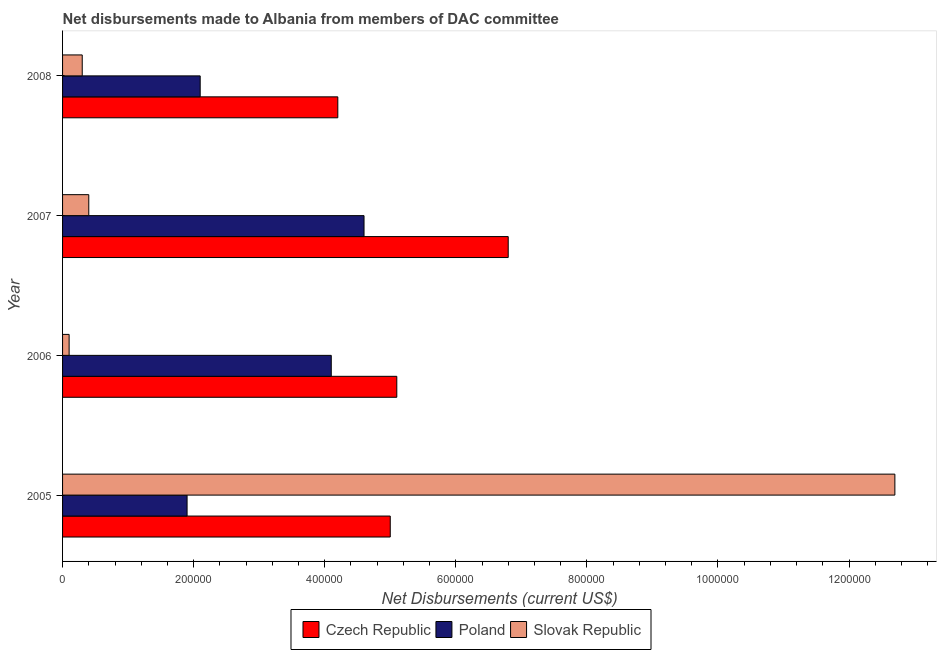How many different coloured bars are there?
Your response must be concise. 3. How many groups of bars are there?
Provide a succinct answer. 4. How many bars are there on the 2nd tick from the top?
Make the answer very short. 3. In how many cases, is the number of bars for a given year not equal to the number of legend labels?
Give a very brief answer. 0. What is the net disbursements made by poland in 2007?
Your response must be concise. 4.60e+05. Across all years, what is the maximum net disbursements made by czech republic?
Your answer should be very brief. 6.80e+05. Across all years, what is the minimum net disbursements made by czech republic?
Make the answer very short. 4.20e+05. What is the total net disbursements made by czech republic in the graph?
Offer a very short reply. 2.11e+06. What is the difference between the net disbursements made by slovak republic in 2005 and that in 2007?
Your response must be concise. 1.23e+06. What is the difference between the net disbursements made by poland in 2006 and the net disbursements made by czech republic in 2008?
Make the answer very short. -10000. What is the average net disbursements made by czech republic per year?
Your answer should be very brief. 5.28e+05. In the year 2007, what is the difference between the net disbursements made by czech republic and net disbursements made by slovak republic?
Provide a short and direct response. 6.40e+05. In how many years, is the net disbursements made by poland greater than 200000 US$?
Your answer should be very brief. 3. What is the ratio of the net disbursements made by czech republic in 2005 to that in 2008?
Provide a succinct answer. 1.19. Is the net disbursements made by czech republic in 2006 less than that in 2007?
Provide a succinct answer. Yes. Is the difference between the net disbursements made by czech republic in 2007 and 2008 greater than the difference between the net disbursements made by poland in 2007 and 2008?
Give a very brief answer. Yes. What is the difference between the highest and the second highest net disbursements made by czech republic?
Your answer should be very brief. 1.70e+05. What is the difference between the highest and the lowest net disbursements made by poland?
Provide a short and direct response. 2.70e+05. What does the 1st bar from the top in 2007 represents?
Provide a short and direct response. Slovak Republic. How many bars are there?
Provide a short and direct response. 12. Are all the bars in the graph horizontal?
Provide a short and direct response. Yes. Are the values on the major ticks of X-axis written in scientific E-notation?
Provide a succinct answer. No. Does the graph contain any zero values?
Keep it short and to the point. No. Does the graph contain grids?
Keep it short and to the point. No. How many legend labels are there?
Keep it short and to the point. 3. What is the title of the graph?
Ensure brevity in your answer.  Net disbursements made to Albania from members of DAC committee. Does "Industrial Nitrous Oxide" appear as one of the legend labels in the graph?
Make the answer very short. No. What is the label or title of the X-axis?
Your response must be concise. Net Disbursements (current US$). What is the Net Disbursements (current US$) of Czech Republic in 2005?
Give a very brief answer. 5.00e+05. What is the Net Disbursements (current US$) in Poland in 2005?
Keep it short and to the point. 1.90e+05. What is the Net Disbursements (current US$) of Slovak Republic in 2005?
Keep it short and to the point. 1.27e+06. What is the Net Disbursements (current US$) in Czech Republic in 2006?
Make the answer very short. 5.10e+05. What is the Net Disbursements (current US$) of Poland in 2006?
Give a very brief answer. 4.10e+05. What is the Net Disbursements (current US$) of Czech Republic in 2007?
Keep it short and to the point. 6.80e+05. What is the Net Disbursements (current US$) in Poland in 2007?
Offer a terse response. 4.60e+05. What is the Net Disbursements (current US$) of Poland in 2008?
Offer a terse response. 2.10e+05. Across all years, what is the maximum Net Disbursements (current US$) in Czech Republic?
Offer a very short reply. 6.80e+05. Across all years, what is the maximum Net Disbursements (current US$) of Slovak Republic?
Provide a succinct answer. 1.27e+06. Across all years, what is the minimum Net Disbursements (current US$) in Czech Republic?
Provide a succinct answer. 4.20e+05. Across all years, what is the minimum Net Disbursements (current US$) in Poland?
Provide a succinct answer. 1.90e+05. Across all years, what is the minimum Net Disbursements (current US$) of Slovak Republic?
Offer a terse response. 10000. What is the total Net Disbursements (current US$) of Czech Republic in the graph?
Ensure brevity in your answer.  2.11e+06. What is the total Net Disbursements (current US$) in Poland in the graph?
Offer a terse response. 1.27e+06. What is the total Net Disbursements (current US$) of Slovak Republic in the graph?
Keep it short and to the point. 1.35e+06. What is the difference between the Net Disbursements (current US$) of Poland in 2005 and that in 2006?
Your answer should be very brief. -2.20e+05. What is the difference between the Net Disbursements (current US$) in Slovak Republic in 2005 and that in 2006?
Ensure brevity in your answer.  1.26e+06. What is the difference between the Net Disbursements (current US$) in Czech Republic in 2005 and that in 2007?
Your response must be concise. -1.80e+05. What is the difference between the Net Disbursements (current US$) of Slovak Republic in 2005 and that in 2007?
Provide a succinct answer. 1.23e+06. What is the difference between the Net Disbursements (current US$) of Czech Republic in 2005 and that in 2008?
Keep it short and to the point. 8.00e+04. What is the difference between the Net Disbursements (current US$) of Poland in 2005 and that in 2008?
Make the answer very short. -2.00e+04. What is the difference between the Net Disbursements (current US$) of Slovak Republic in 2005 and that in 2008?
Ensure brevity in your answer.  1.24e+06. What is the difference between the Net Disbursements (current US$) of Poland in 2006 and that in 2007?
Give a very brief answer. -5.00e+04. What is the difference between the Net Disbursements (current US$) in Slovak Republic in 2006 and that in 2007?
Provide a succinct answer. -3.00e+04. What is the difference between the Net Disbursements (current US$) of Czech Republic in 2006 and that in 2008?
Keep it short and to the point. 9.00e+04. What is the difference between the Net Disbursements (current US$) in Poland in 2006 and that in 2008?
Give a very brief answer. 2.00e+05. What is the difference between the Net Disbursements (current US$) in Poland in 2007 and that in 2008?
Your answer should be very brief. 2.50e+05. What is the difference between the Net Disbursements (current US$) in Czech Republic in 2005 and the Net Disbursements (current US$) in Poland in 2006?
Offer a very short reply. 9.00e+04. What is the difference between the Net Disbursements (current US$) of Czech Republic in 2005 and the Net Disbursements (current US$) of Slovak Republic in 2006?
Give a very brief answer. 4.90e+05. What is the difference between the Net Disbursements (current US$) in Poland in 2005 and the Net Disbursements (current US$) in Slovak Republic in 2006?
Your answer should be compact. 1.80e+05. What is the difference between the Net Disbursements (current US$) of Czech Republic in 2005 and the Net Disbursements (current US$) of Poland in 2007?
Your answer should be compact. 4.00e+04. What is the difference between the Net Disbursements (current US$) of Czech Republic in 2005 and the Net Disbursements (current US$) of Poland in 2008?
Offer a very short reply. 2.90e+05. What is the difference between the Net Disbursements (current US$) in Czech Republic in 2005 and the Net Disbursements (current US$) in Slovak Republic in 2008?
Ensure brevity in your answer.  4.70e+05. What is the difference between the Net Disbursements (current US$) in Czech Republic in 2006 and the Net Disbursements (current US$) in Poland in 2007?
Your answer should be compact. 5.00e+04. What is the difference between the Net Disbursements (current US$) of Czech Republic in 2006 and the Net Disbursements (current US$) of Slovak Republic in 2007?
Offer a terse response. 4.70e+05. What is the difference between the Net Disbursements (current US$) in Poland in 2006 and the Net Disbursements (current US$) in Slovak Republic in 2008?
Ensure brevity in your answer.  3.80e+05. What is the difference between the Net Disbursements (current US$) of Czech Republic in 2007 and the Net Disbursements (current US$) of Poland in 2008?
Give a very brief answer. 4.70e+05. What is the difference between the Net Disbursements (current US$) in Czech Republic in 2007 and the Net Disbursements (current US$) in Slovak Republic in 2008?
Your answer should be very brief. 6.50e+05. What is the average Net Disbursements (current US$) of Czech Republic per year?
Provide a short and direct response. 5.28e+05. What is the average Net Disbursements (current US$) in Poland per year?
Ensure brevity in your answer.  3.18e+05. What is the average Net Disbursements (current US$) in Slovak Republic per year?
Your response must be concise. 3.38e+05. In the year 2005, what is the difference between the Net Disbursements (current US$) in Czech Republic and Net Disbursements (current US$) in Slovak Republic?
Offer a terse response. -7.70e+05. In the year 2005, what is the difference between the Net Disbursements (current US$) of Poland and Net Disbursements (current US$) of Slovak Republic?
Make the answer very short. -1.08e+06. In the year 2007, what is the difference between the Net Disbursements (current US$) of Czech Republic and Net Disbursements (current US$) of Slovak Republic?
Your answer should be compact. 6.40e+05. In the year 2008, what is the difference between the Net Disbursements (current US$) in Poland and Net Disbursements (current US$) in Slovak Republic?
Your answer should be compact. 1.80e+05. What is the ratio of the Net Disbursements (current US$) of Czech Republic in 2005 to that in 2006?
Ensure brevity in your answer.  0.98. What is the ratio of the Net Disbursements (current US$) in Poland in 2005 to that in 2006?
Your answer should be compact. 0.46. What is the ratio of the Net Disbursements (current US$) in Slovak Republic in 2005 to that in 2006?
Your response must be concise. 127. What is the ratio of the Net Disbursements (current US$) in Czech Republic in 2005 to that in 2007?
Provide a short and direct response. 0.74. What is the ratio of the Net Disbursements (current US$) of Poland in 2005 to that in 2007?
Ensure brevity in your answer.  0.41. What is the ratio of the Net Disbursements (current US$) of Slovak Republic in 2005 to that in 2007?
Provide a succinct answer. 31.75. What is the ratio of the Net Disbursements (current US$) in Czech Republic in 2005 to that in 2008?
Make the answer very short. 1.19. What is the ratio of the Net Disbursements (current US$) in Poland in 2005 to that in 2008?
Your answer should be compact. 0.9. What is the ratio of the Net Disbursements (current US$) of Slovak Republic in 2005 to that in 2008?
Provide a succinct answer. 42.33. What is the ratio of the Net Disbursements (current US$) of Poland in 2006 to that in 2007?
Keep it short and to the point. 0.89. What is the ratio of the Net Disbursements (current US$) of Czech Republic in 2006 to that in 2008?
Keep it short and to the point. 1.21. What is the ratio of the Net Disbursements (current US$) of Poland in 2006 to that in 2008?
Make the answer very short. 1.95. What is the ratio of the Net Disbursements (current US$) in Slovak Republic in 2006 to that in 2008?
Your answer should be compact. 0.33. What is the ratio of the Net Disbursements (current US$) in Czech Republic in 2007 to that in 2008?
Keep it short and to the point. 1.62. What is the ratio of the Net Disbursements (current US$) in Poland in 2007 to that in 2008?
Make the answer very short. 2.19. What is the difference between the highest and the second highest Net Disbursements (current US$) in Czech Republic?
Offer a terse response. 1.70e+05. What is the difference between the highest and the second highest Net Disbursements (current US$) in Poland?
Your answer should be compact. 5.00e+04. What is the difference between the highest and the second highest Net Disbursements (current US$) in Slovak Republic?
Give a very brief answer. 1.23e+06. What is the difference between the highest and the lowest Net Disbursements (current US$) in Slovak Republic?
Make the answer very short. 1.26e+06. 